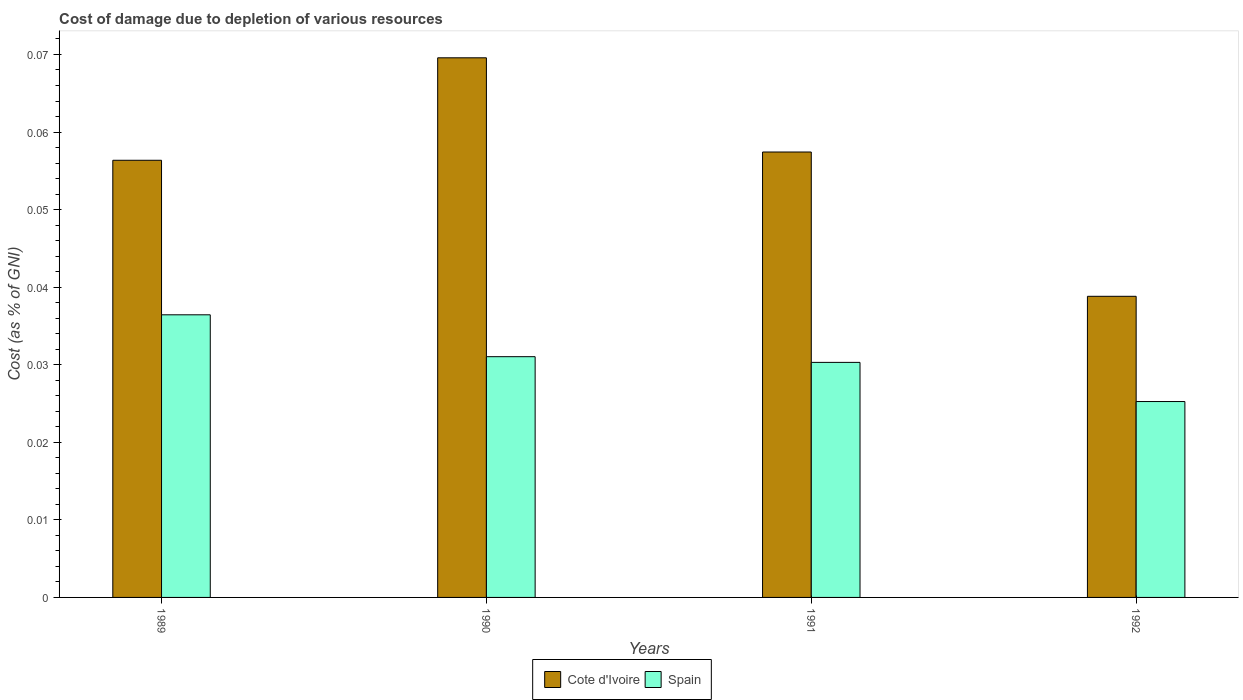Are the number of bars on each tick of the X-axis equal?
Provide a succinct answer. Yes. How many bars are there on the 1st tick from the left?
Offer a very short reply. 2. In how many cases, is the number of bars for a given year not equal to the number of legend labels?
Offer a terse response. 0. What is the cost of damage caused due to the depletion of various resources in Cote d'Ivoire in 1990?
Give a very brief answer. 0.07. Across all years, what is the maximum cost of damage caused due to the depletion of various resources in Spain?
Your answer should be compact. 0.04. Across all years, what is the minimum cost of damage caused due to the depletion of various resources in Spain?
Your response must be concise. 0.03. In which year was the cost of damage caused due to the depletion of various resources in Cote d'Ivoire maximum?
Your answer should be compact. 1990. What is the total cost of damage caused due to the depletion of various resources in Cote d'Ivoire in the graph?
Ensure brevity in your answer.  0.22. What is the difference between the cost of damage caused due to the depletion of various resources in Spain in 1990 and that in 1992?
Ensure brevity in your answer.  0.01. What is the difference between the cost of damage caused due to the depletion of various resources in Spain in 1992 and the cost of damage caused due to the depletion of various resources in Cote d'Ivoire in 1991?
Your response must be concise. -0.03. What is the average cost of damage caused due to the depletion of various resources in Cote d'Ivoire per year?
Your response must be concise. 0.06. In the year 1992, what is the difference between the cost of damage caused due to the depletion of various resources in Spain and cost of damage caused due to the depletion of various resources in Cote d'Ivoire?
Your answer should be very brief. -0.01. What is the ratio of the cost of damage caused due to the depletion of various resources in Cote d'Ivoire in 1989 to that in 1991?
Provide a succinct answer. 0.98. What is the difference between the highest and the second highest cost of damage caused due to the depletion of various resources in Spain?
Provide a short and direct response. 0.01. What is the difference between the highest and the lowest cost of damage caused due to the depletion of various resources in Cote d'Ivoire?
Offer a terse response. 0.03. In how many years, is the cost of damage caused due to the depletion of various resources in Spain greater than the average cost of damage caused due to the depletion of various resources in Spain taken over all years?
Make the answer very short. 2. What does the 1st bar from the left in 1990 represents?
Offer a terse response. Cote d'Ivoire. What does the 1st bar from the right in 1989 represents?
Give a very brief answer. Spain. Are all the bars in the graph horizontal?
Your answer should be very brief. No. How many years are there in the graph?
Your response must be concise. 4. Are the values on the major ticks of Y-axis written in scientific E-notation?
Your answer should be very brief. No. Does the graph contain grids?
Provide a short and direct response. No. Where does the legend appear in the graph?
Make the answer very short. Bottom center. How many legend labels are there?
Provide a succinct answer. 2. How are the legend labels stacked?
Offer a terse response. Horizontal. What is the title of the graph?
Keep it short and to the point. Cost of damage due to depletion of various resources. What is the label or title of the Y-axis?
Your answer should be very brief. Cost (as % of GNI). What is the Cost (as % of GNI) of Cote d'Ivoire in 1989?
Your response must be concise. 0.06. What is the Cost (as % of GNI) in Spain in 1989?
Keep it short and to the point. 0.04. What is the Cost (as % of GNI) in Cote d'Ivoire in 1990?
Ensure brevity in your answer.  0.07. What is the Cost (as % of GNI) in Spain in 1990?
Your response must be concise. 0.03. What is the Cost (as % of GNI) of Cote d'Ivoire in 1991?
Offer a very short reply. 0.06. What is the Cost (as % of GNI) in Spain in 1991?
Offer a very short reply. 0.03. What is the Cost (as % of GNI) in Cote d'Ivoire in 1992?
Your answer should be very brief. 0.04. What is the Cost (as % of GNI) in Spain in 1992?
Your answer should be very brief. 0.03. Across all years, what is the maximum Cost (as % of GNI) in Cote d'Ivoire?
Provide a succinct answer. 0.07. Across all years, what is the maximum Cost (as % of GNI) in Spain?
Provide a short and direct response. 0.04. Across all years, what is the minimum Cost (as % of GNI) in Cote d'Ivoire?
Keep it short and to the point. 0.04. Across all years, what is the minimum Cost (as % of GNI) of Spain?
Give a very brief answer. 0.03. What is the total Cost (as % of GNI) in Cote d'Ivoire in the graph?
Offer a very short reply. 0.22. What is the total Cost (as % of GNI) in Spain in the graph?
Your answer should be compact. 0.12. What is the difference between the Cost (as % of GNI) in Cote d'Ivoire in 1989 and that in 1990?
Your response must be concise. -0.01. What is the difference between the Cost (as % of GNI) in Spain in 1989 and that in 1990?
Your answer should be compact. 0.01. What is the difference between the Cost (as % of GNI) of Cote d'Ivoire in 1989 and that in 1991?
Provide a short and direct response. -0. What is the difference between the Cost (as % of GNI) in Spain in 1989 and that in 1991?
Provide a short and direct response. 0.01. What is the difference between the Cost (as % of GNI) of Cote d'Ivoire in 1989 and that in 1992?
Give a very brief answer. 0.02. What is the difference between the Cost (as % of GNI) in Spain in 1989 and that in 1992?
Make the answer very short. 0.01. What is the difference between the Cost (as % of GNI) in Cote d'Ivoire in 1990 and that in 1991?
Provide a succinct answer. 0.01. What is the difference between the Cost (as % of GNI) in Spain in 1990 and that in 1991?
Your response must be concise. 0. What is the difference between the Cost (as % of GNI) in Cote d'Ivoire in 1990 and that in 1992?
Your answer should be very brief. 0.03. What is the difference between the Cost (as % of GNI) in Spain in 1990 and that in 1992?
Your answer should be compact. 0.01. What is the difference between the Cost (as % of GNI) in Cote d'Ivoire in 1991 and that in 1992?
Provide a succinct answer. 0.02. What is the difference between the Cost (as % of GNI) of Spain in 1991 and that in 1992?
Make the answer very short. 0.01. What is the difference between the Cost (as % of GNI) in Cote d'Ivoire in 1989 and the Cost (as % of GNI) in Spain in 1990?
Give a very brief answer. 0.03. What is the difference between the Cost (as % of GNI) in Cote d'Ivoire in 1989 and the Cost (as % of GNI) in Spain in 1991?
Your answer should be very brief. 0.03. What is the difference between the Cost (as % of GNI) of Cote d'Ivoire in 1989 and the Cost (as % of GNI) of Spain in 1992?
Offer a terse response. 0.03. What is the difference between the Cost (as % of GNI) of Cote d'Ivoire in 1990 and the Cost (as % of GNI) of Spain in 1991?
Your answer should be very brief. 0.04. What is the difference between the Cost (as % of GNI) of Cote d'Ivoire in 1990 and the Cost (as % of GNI) of Spain in 1992?
Provide a short and direct response. 0.04. What is the difference between the Cost (as % of GNI) in Cote d'Ivoire in 1991 and the Cost (as % of GNI) in Spain in 1992?
Keep it short and to the point. 0.03. What is the average Cost (as % of GNI) in Cote d'Ivoire per year?
Ensure brevity in your answer.  0.06. What is the average Cost (as % of GNI) of Spain per year?
Offer a very short reply. 0.03. In the year 1989, what is the difference between the Cost (as % of GNI) in Cote d'Ivoire and Cost (as % of GNI) in Spain?
Keep it short and to the point. 0.02. In the year 1990, what is the difference between the Cost (as % of GNI) in Cote d'Ivoire and Cost (as % of GNI) in Spain?
Provide a short and direct response. 0.04. In the year 1991, what is the difference between the Cost (as % of GNI) in Cote d'Ivoire and Cost (as % of GNI) in Spain?
Provide a short and direct response. 0.03. In the year 1992, what is the difference between the Cost (as % of GNI) of Cote d'Ivoire and Cost (as % of GNI) of Spain?
Your answer should be very brief. 0.01. What is the ratio of the Cost (as % of GNI) in Cote d'Ivoire in 1989 to that in 1990?
Ensure brevity in your answer.  0.81. What is the ratio of the Cost (as % of GNI) in Spain in 1989 to that in 1990?
Your answer should be compact. 1.17. What is the ratio of the Cost (as % of GNI) of Cote d'Ivoire in 1989 to that in 1991?
Give a very brief answer. 0.98. What is the ratio of the Cost (as % of GNI) of Spain in 1989 to that in 1991?
Offer a terse response. 1.2. What is the ratio of the Cost (as % of GNI) in Cote d'Ivoire in 1989 to that in 1992?
Give a very brief answer. 1.45. What is the ratio of the Cost (as % of GNI) in Spain in 1989 to that in 1992?
Ensure brevity in your answer.  1.44. What is the ratio of the Cost (as % of GNI) of Cote d'Ivoire in 1990 to that in 1991?
Your answer should be very brief. 1.21. What is the ratio of the Cost (as % of GNI) of Spain in 1990 to that in 1991?
Provide a succinct answer. 1.02. What is the ratio of the Cost (as % of GNI) of Cote d'Ivoire in 1990 to that in 1992?
Your response must be concise. 1.79. What is the ratio of the Cost (as % of GNI) of Spain in 1990 to that in 1992?
Make the answer very short. 1.23. What is the ratio of the Cost (as % of GNI) in Cote d'Ivoire in 1991 to that in 1992?
Keep it short and to the point. 1.48. What is the ratio of the Cost (as % of GNI) in Spain in 1991 to that in 1992?
Provide a short and direct response. 1.2. What is the difference between the highest and the second highest Cost (as % of GNI) of Cote d'Ivoire?
Offer a terse response. 0.01. What is the difference between the highest and the second highest Cost (as % of GNI) in Spain?
Provide a succinct answer. 0.01. What is the difference between the highest and the lowest Cost (as % of GNI) in Cote d'Ivoire?
Your answer should be very brief. 0.03. What is the difference between the highest and the lowest Cost (as % of GNI) of Spain?
Keep it short and to the point. 0.01. 